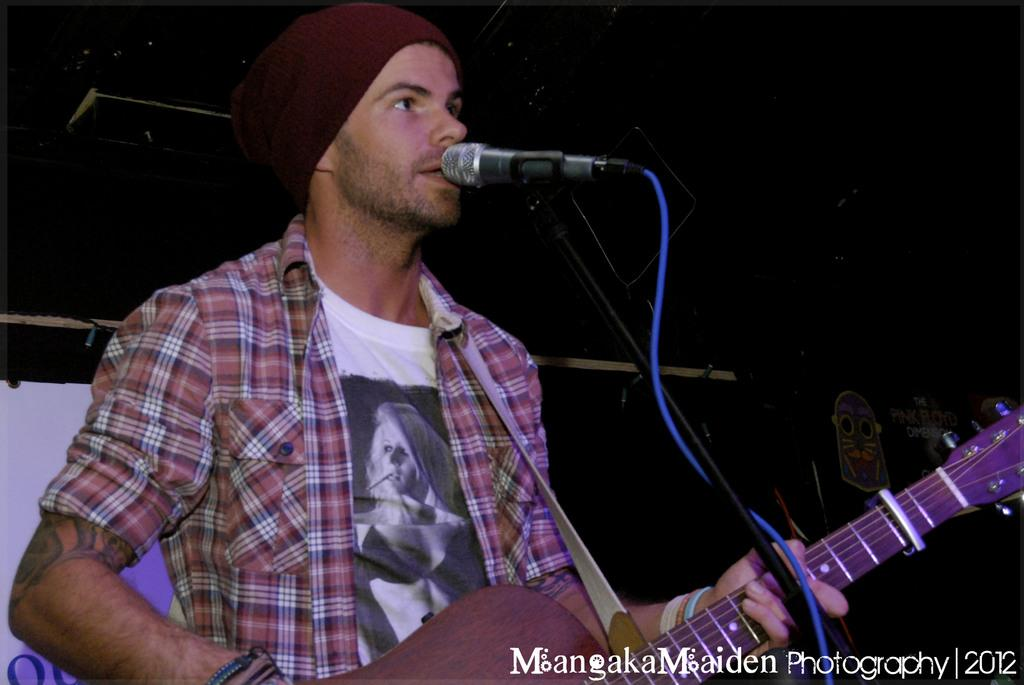Who is the main subject in the image? There is a person in the image. What is the person holding in the image? The person is holding a guitar. What is the person doing with the guitar? The person is playing the guitar. What other object is present in the image? There is a microphone in the image. What is the person doing with the microphone? The person is singing through the microphone. What type of beetle can be seen crawling on the guitar in the image? There is no beetle present in the image; the guitar is being played by the person. 